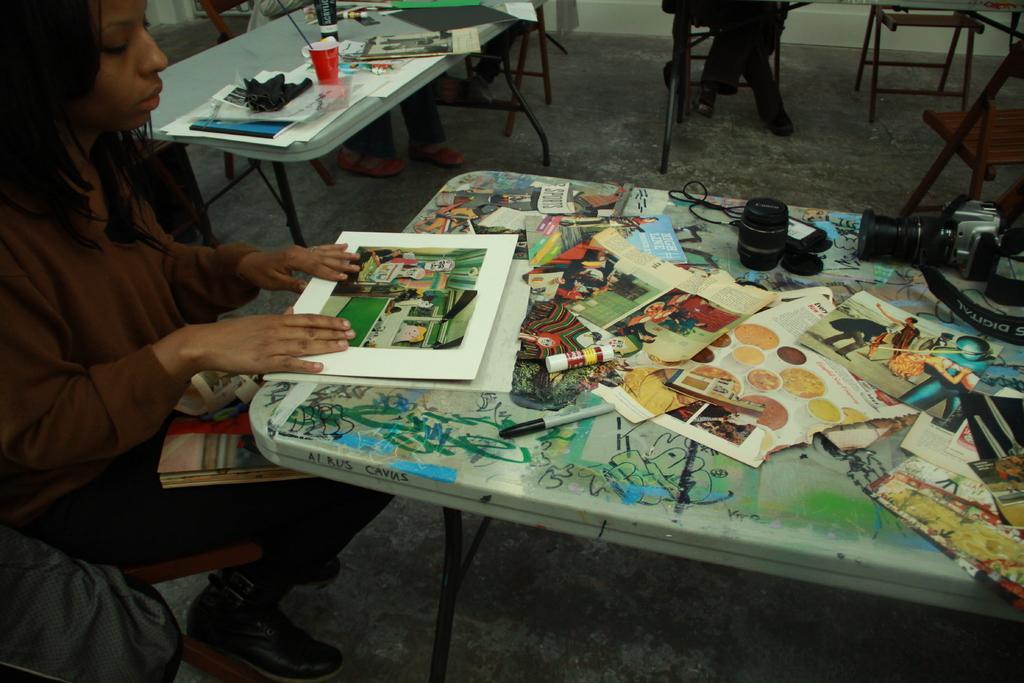Can you describe this image briefly? In the middle there is a table on that table there is a pen ,camera ,paper and some other items , In front of the table there is a woman she wear brown t shirt , trouser and shoes , her hair is short. In the background there is a table ,chair some people and wall. 